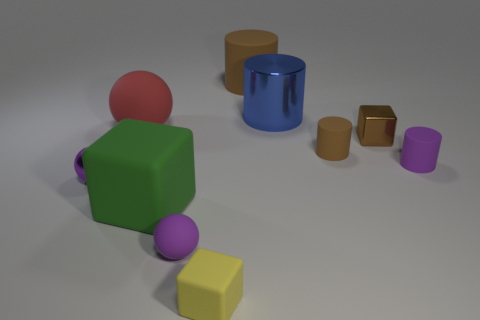What is the size of the blue metallic cylinder?
Offer a very short reply. Large. There is a yellow rubber thing on the left side of the large shiny cylinder; how many big matte spheres are in front of it?
Offer a very short reply. 0. The metallic object that is on the left side of the metal cube and in front of the large red ball has what shape?
Your answer should be compact. Sphere. What number of tiny things have the same color as the shiny cylinder?
Offer a very short reply. 0. Are there any small yellow blocks right of the large cylinder that is to the right of the rubber thing behind the red rubber thing?
Your response must be concise. No. There is a ball that is both in front of the red rubber object and on the right side of the purple metallic ball; how big is it?
Give a very brief answer. Small. What number of small cylinders have the same material as the tiny brown block?
Your response must be concise. 0. How many blocks are large red objects or big things?
Make the answer very short. 1. There is a purple ball in front of the metallic thing that is to the left of the large cylinder in front of the large rubber cylinder; what is its size?
Offer a terse response. Small. The metal object that is in front of the red sphere and right of the red rubber thing is what color?
Ensure brevity in your answer.  Brown. 